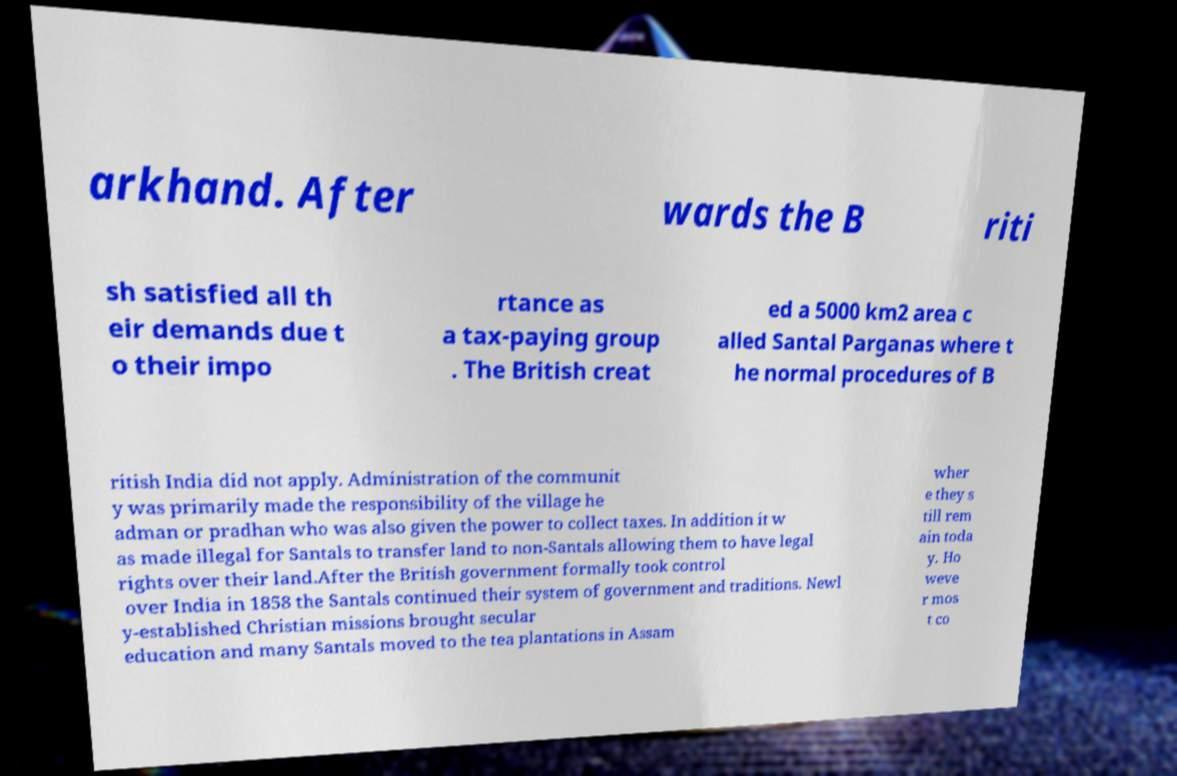Could you extract and type out the text from this image? arkhand. After wards the B riti sh satisfied all th eir demands due t o their impo rtance as a tax-paying group . The British creat ed a 5000 km2 area c alled Santal Parganas where t he normal procedures of B ritish India did not apply. Administration of the communit y was primarily made the responsibility of the village he adman or pradhan who was also given the power to collect taxes. In addition it w as made illegal for Santals to transfer land to non-Santals allowing them to have legal rights over their land.After the British government formally took control over India in 1858 the Santals continued their system of government and traditions. Newl y-established Christian missions brought secular education and many Santals moved to the tea plantations in Assam wher e they s till rem ain toda y. Ho weve r mos t co 